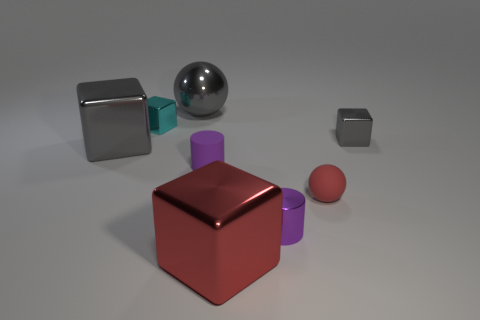Add 1 big yellow rubber spheres. How many objects exist? 9 Subtract all cylinders. How many objects are left? 6 Subtract 1 red cubes. How many objects are left? 7 Subtract all green metal cylinders. Subtract all purple matte things. How many objects are left? 7 Add 3 big metal cubes. How many big metal cubes are left? 5 Add 6 small purple metal things. How many small purple metal things exist? 7 